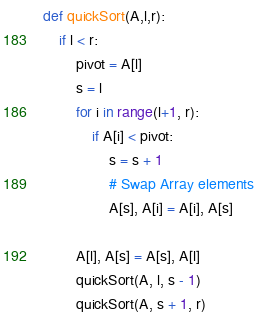<code> <loc_0><loc_0><loc_500><loc_500><_Python_>def quickSort(A,l,r):
	if l < r:
		pivot = A[l]
		s = l
		for i in range(l+1, r):
			if A[i] < pivot:
				s = s + 1
				# Swap Array elements
				A[s], A[i] = A[i], A[s]
		
		A[l], A[s] = A[s], A[l]
		quickSort(A, l, s - 1)
		quickSort(A, s + 1, r)
</code> 